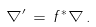<formula> <loc_0><loc_0><loc_500><loc_500>\nabla ^ { \prime } \, = \, f ^ { * } \nabla \, .</formula> 